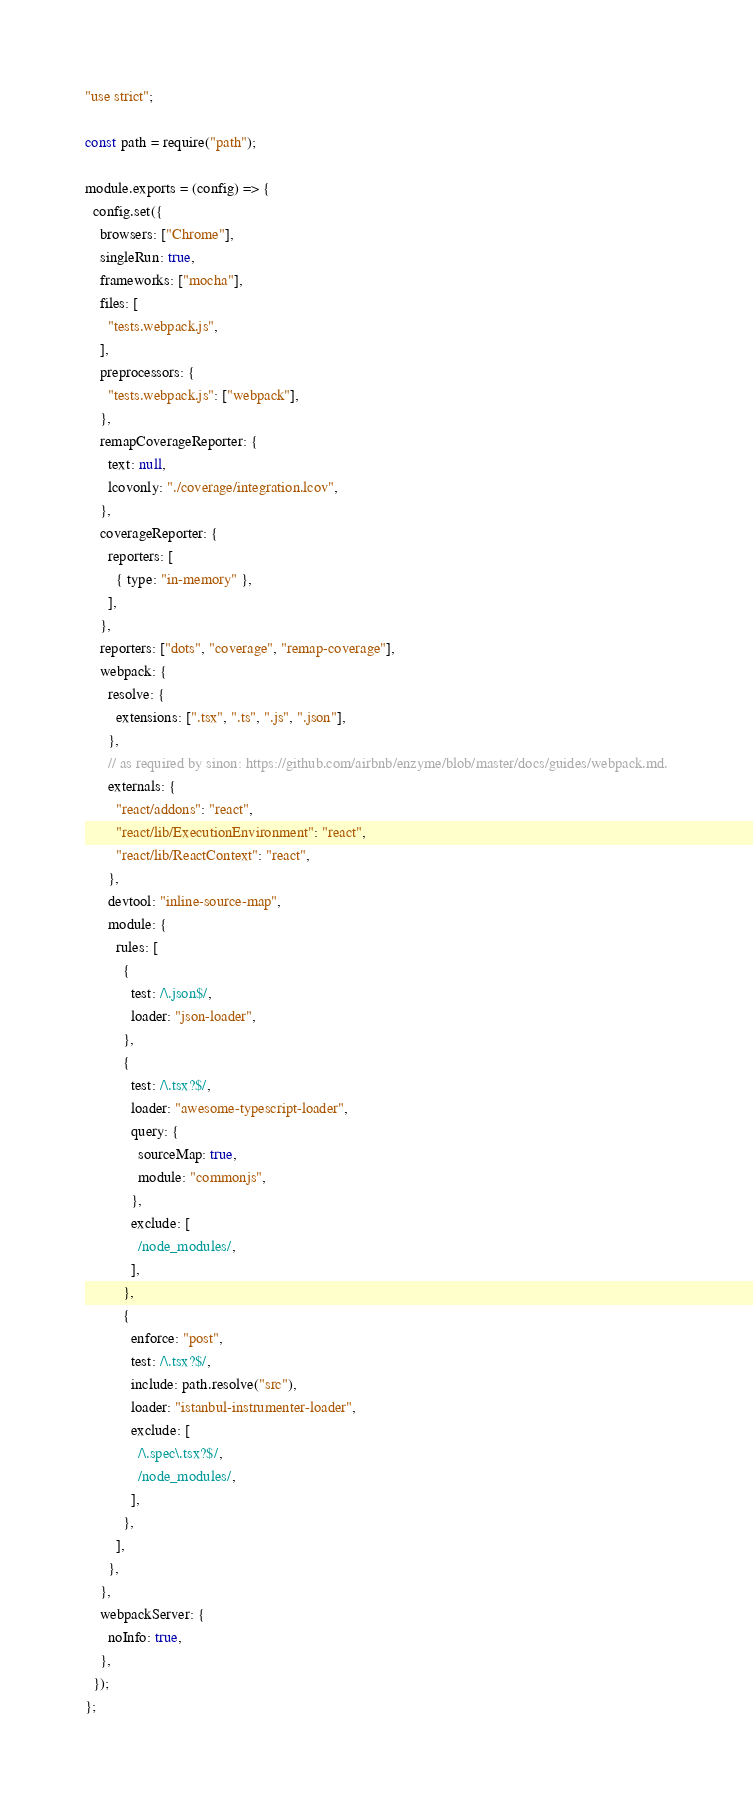Convert code to text. <code><loc_0><loc_0><loc_500><loc_500><_JavaScript_>"use strict";

const path = require("path");

module.exports = (config) => {
  config.set({
    browsers: ["Chrome"],
    singleRun: true,
    frameworks: ["mocha"],
    files: [
      "tests.webpack.js",
    ],
    preprocessors: {
      "tests.webpack.js": ["webpack"],
    },
    remapCoverageReporter: {
      text: null,
      lcovonly: "./coverage/integration.lcov",
    },
    coverageReporter: {
      reporters: [
        { type: "in-memory" },
      ],
    },
    reporters: ["dots", "coverage", "remap-coverage"],
    webpack: {
      resolve: {
        extensions: [".tsx", ".ts", ".js", ".json"],
      },
      // as required by sinon: https://github.com/airbnb/enzyme/blob/master/docs/guides/webpack.md.
      externals: {
        "react/addons": "react",
        "react/lib/ExecutionEnvironment": "react",
        "react/lib/ReactContext": "react",
      },
      devtool: "inline-source-map",
      module: {
        rules: [
          {
            test: /\.json$/,
            loader: "json-loader",
          },
          {
            test: /\.tsx?$/,
            loader: "awesome-typescript-loader",
            query: {
              sourceMap: true,
              module: "commonjs",
            },
            exclude: [
              /node_modules/,
            ],
          },
          {
            enforce: "post",
            test: /\.tsx?$/,
            include: path.resolve("src"),
            loader: "istanbul-instrumenter-loader",
            exclude: [
              /\.spec\.tsx?$/,
              /node_modules/,
            ],
          },
        ],
      },
    },
    webpackServer: {
      noInfo: true,
    },
  });
};
</code> 